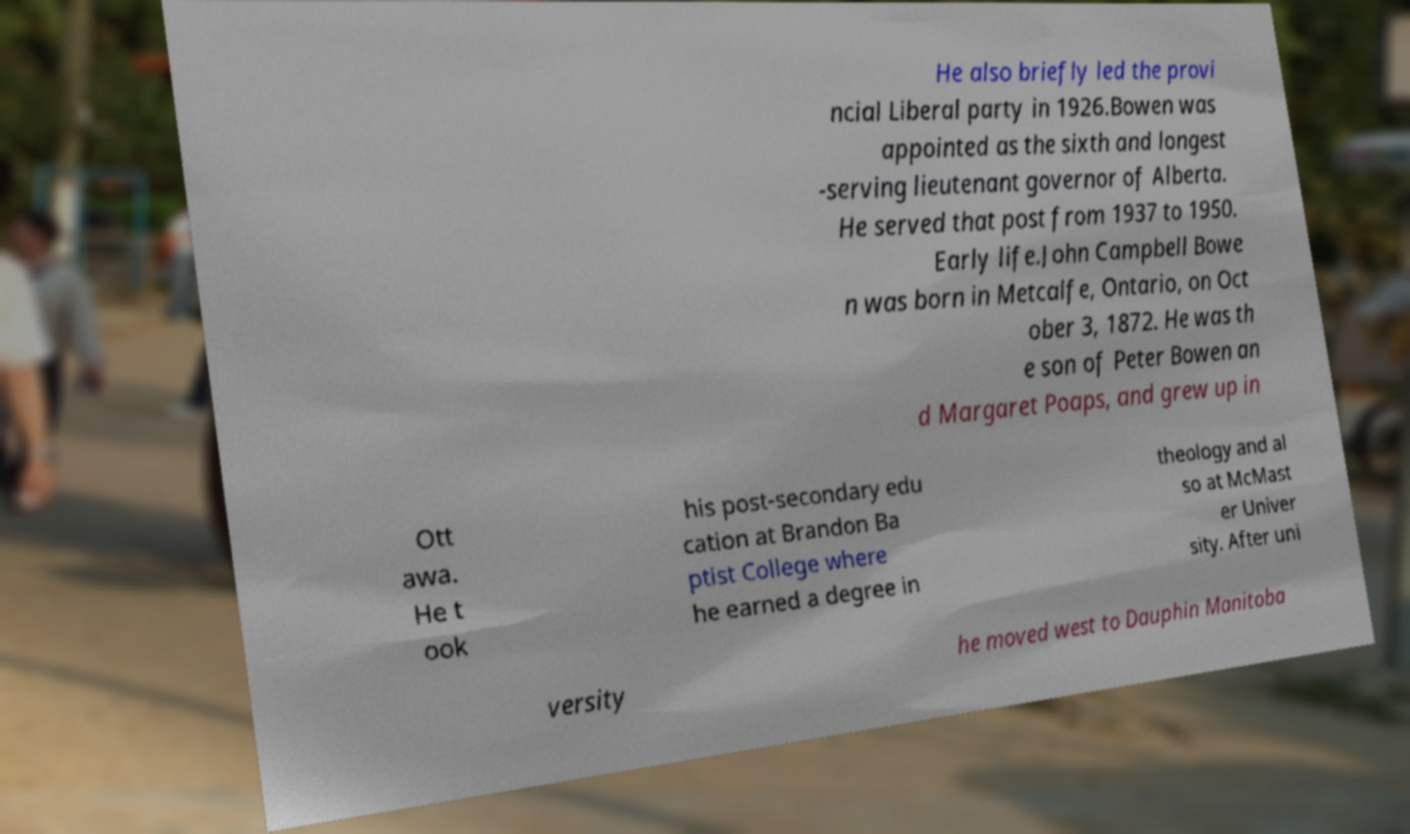Please identify and transcribe the text found in this image. He also briefly led the provi ncial Liberal party in 1926.Bowen was appointed as the sixth and longest -serving lieutenant governor of Alberta. He served that post from 1937 to 1950. Early life.John Campbell Bowe n was born in Metcalfe, Ontario, on Oct ober 3, 1872. He was th e son of Peter Bowen an d Margaret Poaps, and grew up in Ott awa. He t ook his post-secondary edu cation at Brandon Ba ptist College where he earned a degree in theology and al so at McMast er Univer sity. After uni versity he moved west to Dauphin Manitoba 